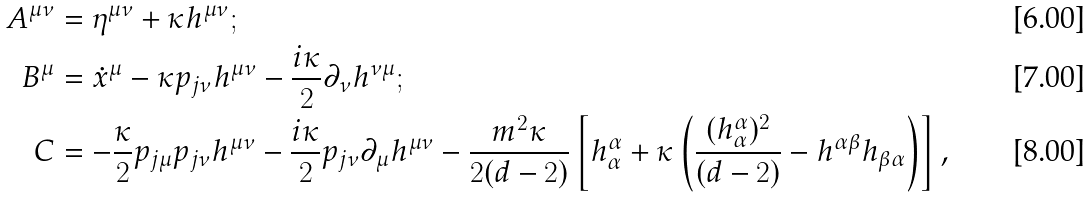<formula> <loc_0><loc_0><loc_500><loc_500>A ^ { \mu \nu } & = \eta ^ { \mu \nu } + \kappa h ^ { \mu \nu } ; \\ B ^ { \mu } & = \dot { x } ^ { \mu } - \kappa p _ { j \nu } h ^ { \mu \nu } - \frac { i \kappa } { 2 } \partial _ { \nu } h ^ { \nu \mu } ; \\ C & = - \frac { \kappa } { 2 } p _ { j \mu } p _ { j \nu } h ^ { \mu \nu } - \frac { i \kappa } { 2 } p _ { j \nu } \partial _ { \mu } h ^ { \mu \nu } - \frac { m ^ { 2 } \kappa } { 2 ( d - 2 ) } \left [ h ^ { \alpha } _ { \alpha } + \kappa \left ( \frac { ( h ^ { \alpha } _ { \alpha } ) ^ { 2 } } { ( d - 2 ) } - h ^ { \alpha \beta } h _ { \beta \alpha } \right ) \right ] ,</formula> 